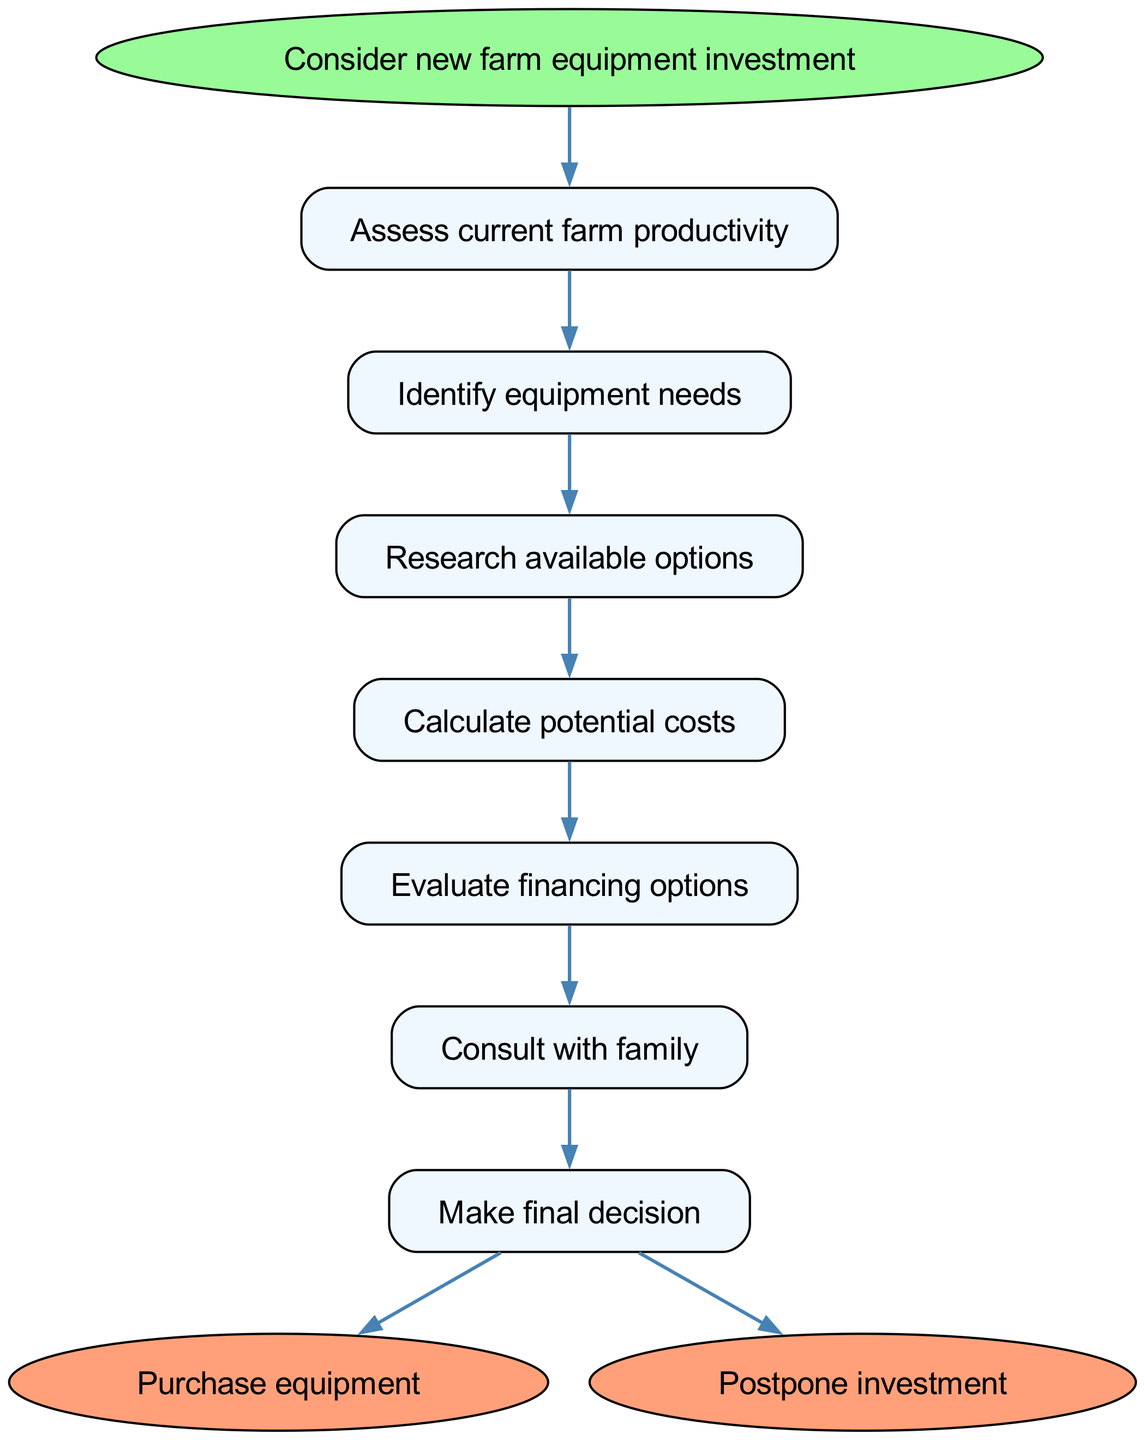What is the starting point of the decision-making process? The starting point is indicated as "Consider new farm equipment investment" in the diagram. This is the initial node from which all decisions stem.
Answer: Consider new farm equipment investment How many decisions are there in the process? The diagram lists six decision nodes, which include assessing productivity, identifying equipment needs, researching options, calculating costs, evaluating financing, and consulting with family.
Answer: 6 What follows after evaluating financing options? The flow indicates that the next step after "Evaluate financing options" is "Consult with family." This shows the sequential nature of the decisions leading towards making a final decision.
Answer: Consult with family If the final decision is not to purchase equipment, what is the alternative action? The diagram shows two possible end outcomes from making the final decision: "Purchase equipment" or "Postpone investment". If the decision is not to purchase, it leads to postponing the investment.
Answer: Postpone investment Which step comes immediately after identifying equipment needs? The flow chart indicates that after "Identify equipment needs," the next step is "Research available options." This sequential relationship between the nodes is crucial for understanding the process.
Answer: Research available options After making a final decision, how many paths can the process take? The diagram illustrates that there are two outcomes after making a final decision: one can either "Purchase equipment" or "Postpone investment." Thus, there are two paths that the process may follow.
Answer: 2 What is the last decision node before reaching an end point? The last decision node before reaching the end points is "Make final decision." This indicates that it is the critical juncture where the decision to act or delay is made.
Answer: Make final decision What is the connection between assessing current farm productivity and the next node? The connection is that the step "Assess current farm productivity" leads directly to "Identify equipment needs," signifying that assessment is a precursor to understanding what equipment is needed.
Answer: Identify equipment needs 